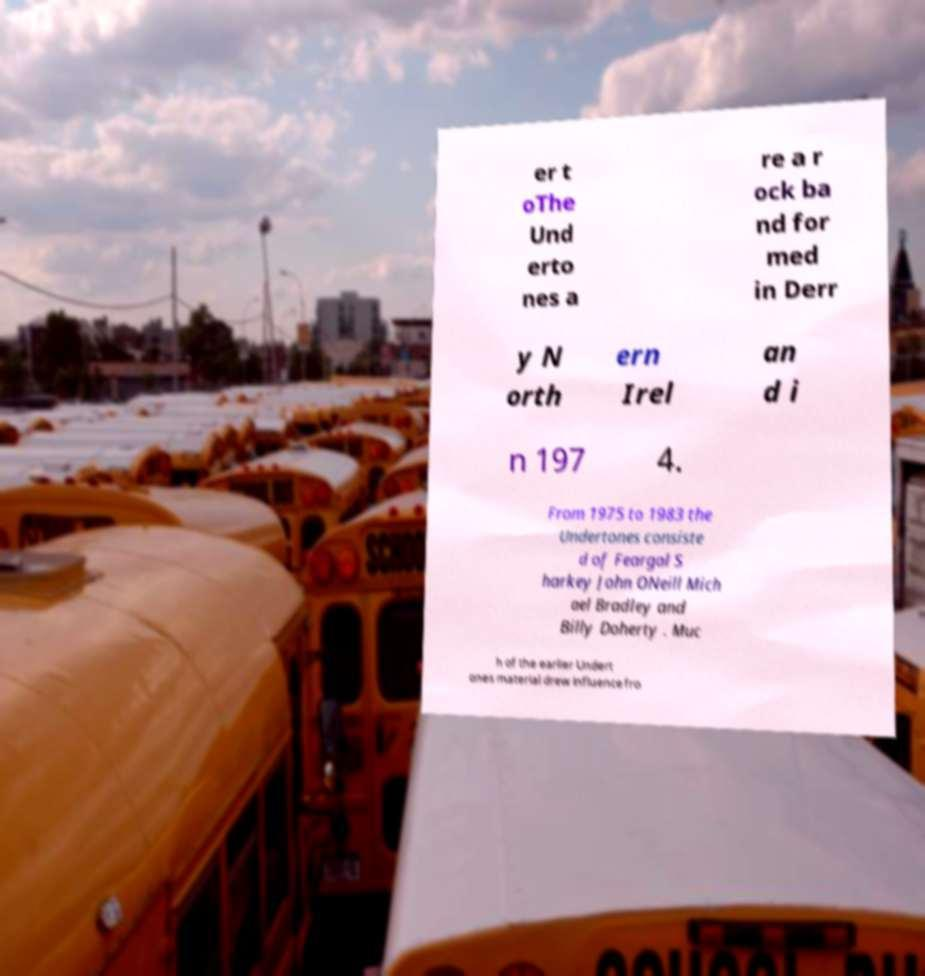I need the written content from this picture converted into text. Can you do that? er t oThe Und erto nes a re a r ock ba nd for med in Derr y N orth ern Irel an d i n 197 4. From 1975 to 1983 the Undertones consiste d of Feargal S harkey John ONeill Mich ael Bradley and Billy Doherty . Muc h of the earlier Undert ones material drew influence fro 